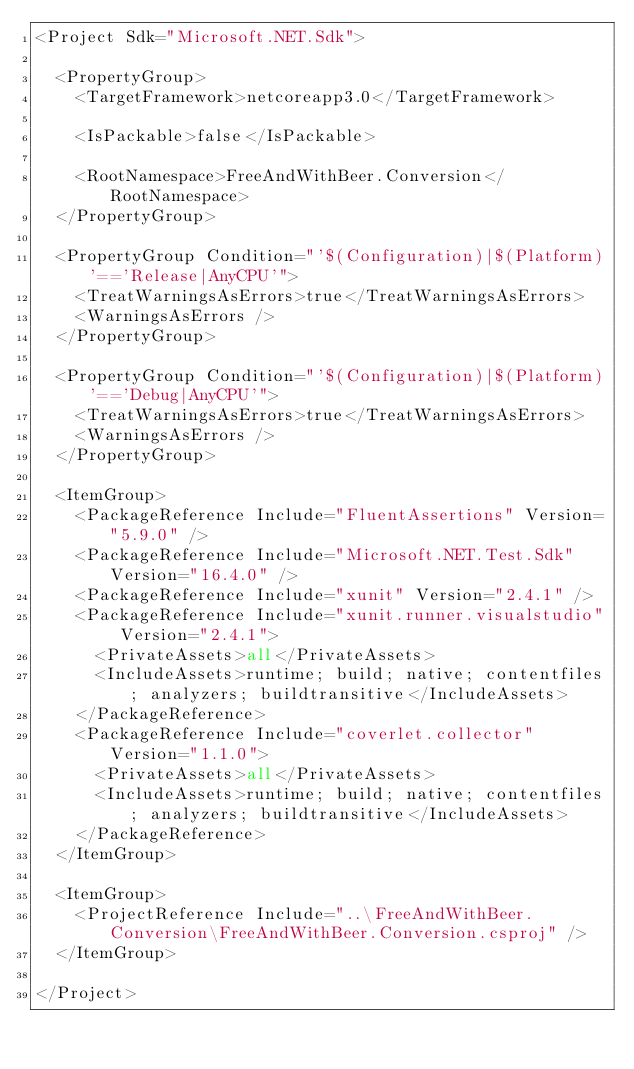Convert code to text. <code><loc_0><loc_0><loc_500><loc_500><_XML_><Project Sdk="Microsoft.NET.Sdk">

  <PropertyGroup>
    <TargetFramework>netcoreapp3.0</TargetFramework>

    <IsPackable>false</IsPackable>

    <RootNamespace>FreeAndWithBeer.Conversion</RootNamespace>
  </PropertyGroup>

  <PropertyGroup Condition="'$(Configuration)|$(Platform)'=='Release|AnyCPU'">
    <TreatWarningsAsErrors>true</TreatWarningsAsErrors>
    <WarningsAsErrors />
  </PropertyGroup>

  <PropertyGroup Condition="'$(Configuration)|$(Platform)'=='Debug|AnyCPU'">
    <TreatWarningsAsErrors>true</TreatWarningsAsErrors>
    <WarningsAsErrors />
  </PropertyGroup>

  <ItemGroup>
    <PackageReference Include="FluentAssertions" Version="5.9.0" />
    <PackageReference Include="Microsoft.NET.Test.Sdk" Version="16.4.0" />
    <PackageReference Include="xunit" Version="2.4.1" />
    <PackageReference Include="xunit.runner.visualstudio" Version="2.4.1">
      <PrivateAssets>all</PrivateAssets>
      <IncludeAssets>runtime; build; native; contentfiles; analyzers; buildtransitive</IncludeAssets>
    </PackageReference>
    <PackageReference Include="coverlet.collector" Version="1.1.0">
      <PrivateAssets>all</PrivateAssets>
      <IncludeAssets>runtime; build; native; contentfiles; analyzers; buildtransitive</IncludeAssets>
    </PackageReference>
  </ItemGroup>

  <ItemGroup>
    <ProjectReference Include="..\FreeAndWithBeer.Conversion\FreeAndWithBeer.Conversion.csproj" />
  </ItemGroup>

</Project>
</code> 